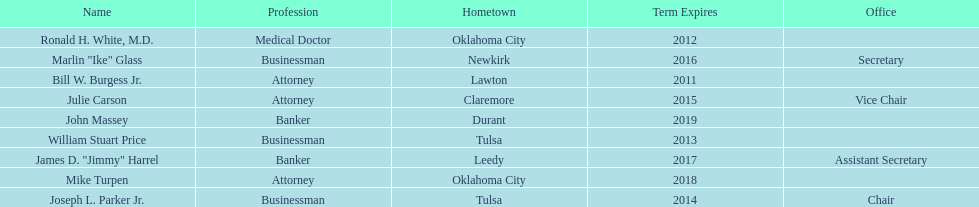Would you be able to parse every entry in this table? {'header': ['Name', 'Profession', 'Hometown', 'Term Expires', 'Office'], 'rows': [['Ronald H. White, M.D.', 'Medical Doctor', 'Oklahoma City', '2012', ''], ['Marlin "Ike" Glass', 'Businessman', 'Newkirk', '2016', 'Secretary'], ['Bill W. Burgess Jr.', 'Attorney', 'Lawton', '2011', ''], ['Julie Carson', 'Attorney', 'Claremore', '2015', 'Vice Chair'], ['John Massey', 'Banker', 'Durant', '2019', ''], ['William Stuart Price', 'Businessman', 'Tulsa', '2013', ''], ['James D. "Jimmy" Harrel', 'Banker', 'Leedy', '2017', 'Assistant Secretary'], ['Mike Turpen', 'Attorney', 'Oklahoma City', '2018', ''], ['Joseph L. Parker Jr.', 'Businessman', 'Tulsa', '2014', 'Chair']]} How many members had businessman listed as their profession? 3. 